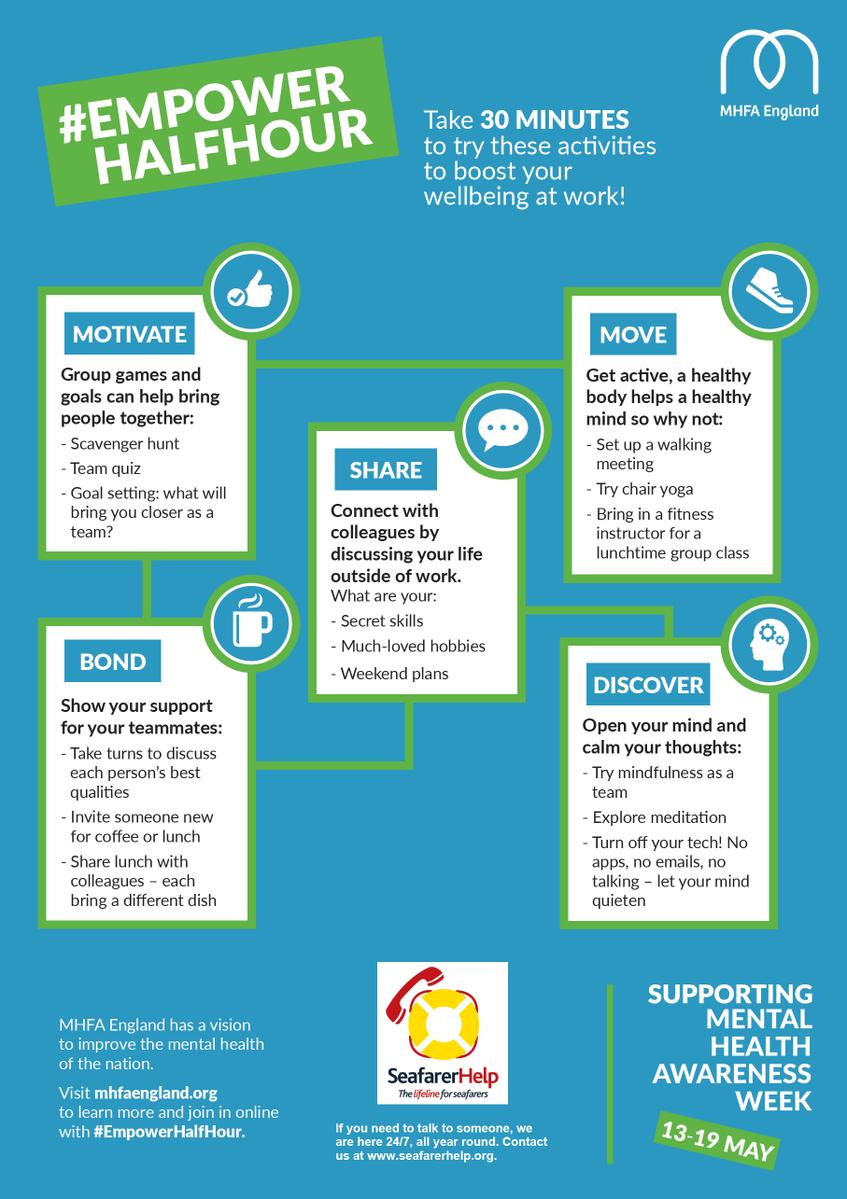Point out several critical features in this image. I can arrange a meeting that promotes physical activity by setting up a walking meeting. The scavenger hunt is the first group game listed. The second suggestion for calming thoughts is to explore meditation. The second group game listed is Team Quiz. 